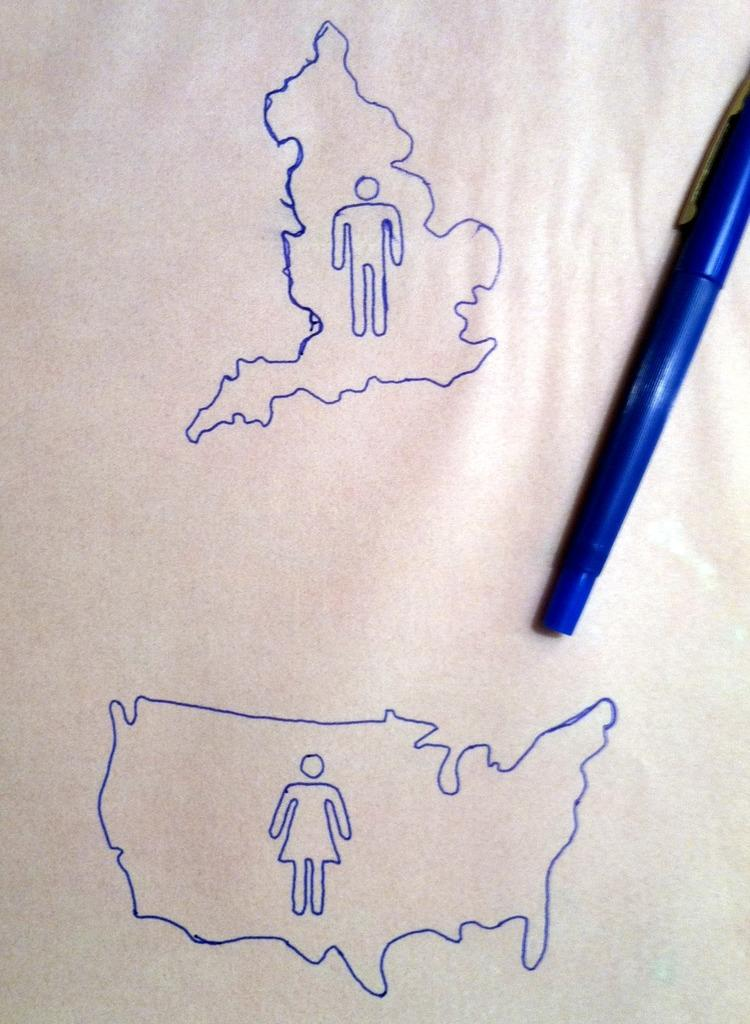What can be seen in the image? There are two diagrams in the image. What color are the diagrams? The diagrams are in blue color. What is the background of the diagrams? The diagrams are on a white paper. What object is present on the right side of the image? There is a pen on the right side of the image. How many letters are addressed to the person in the image? There is no person or letters present in the image; it only contains two diagrams and a pen. 